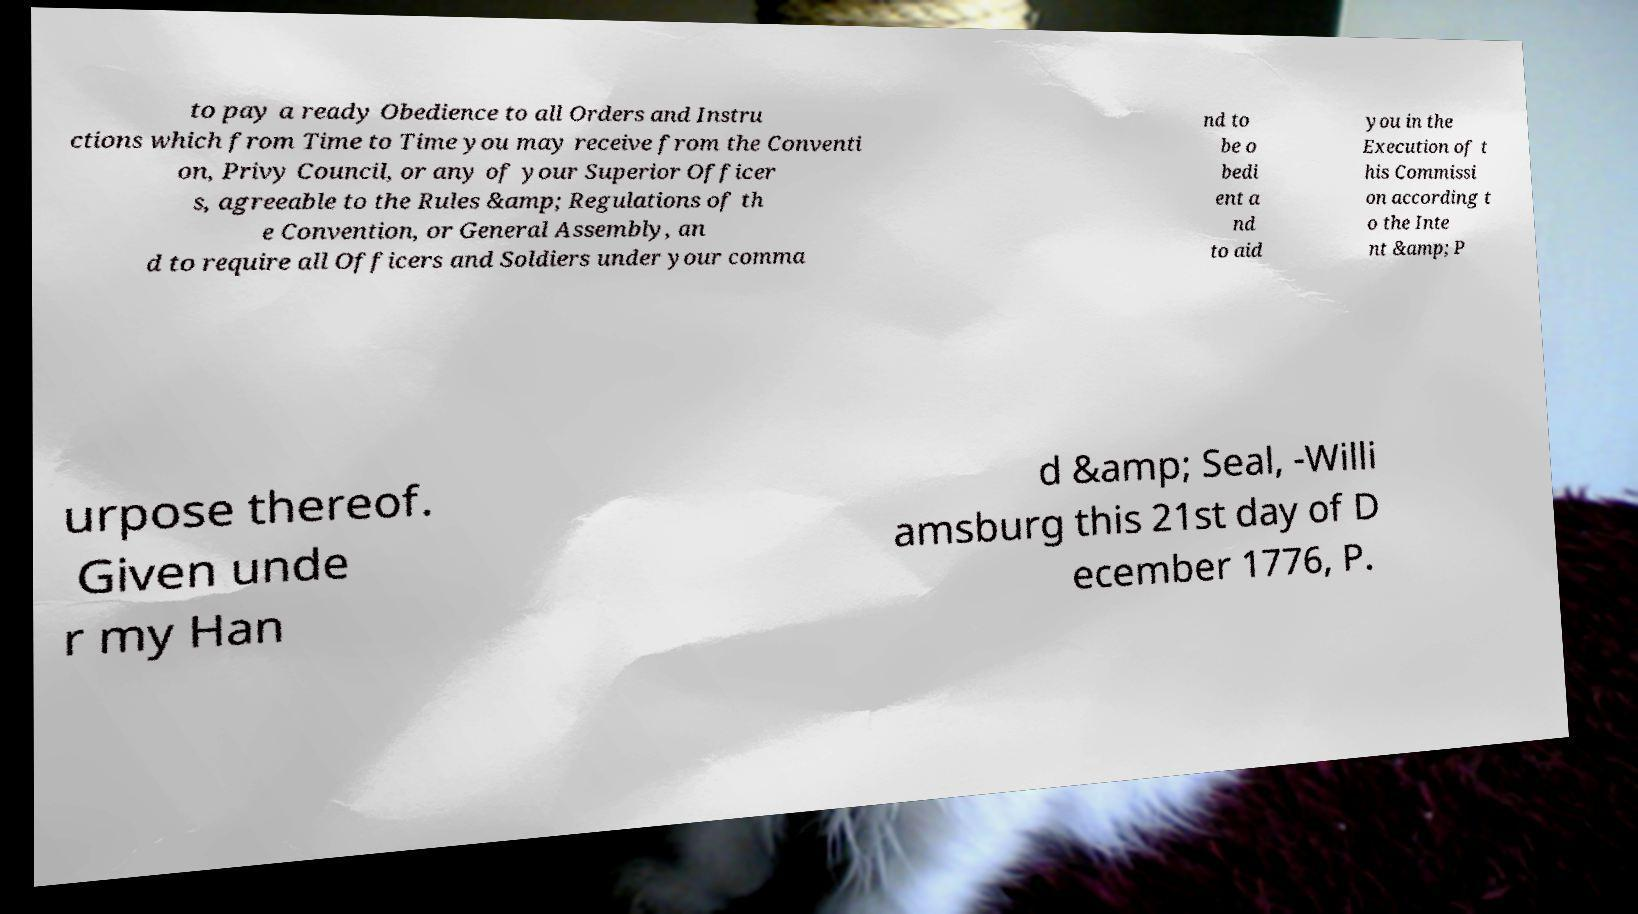I need the written content from this picture converted into text. Can you do that? to pay a ready Obedience to all Orders and Instru ctions which from Time to Time you may receive from the Conventi on, Privy Council, or any of your Superior Officer s, agreeable to the Rules &amp; Regulations of th e Convention, or General Assembly, an d to require all Officers and Soldiers under your comma nd to be o bedi ent a nd to aid you in the Execution of t his Commissi on according t o the Inte nt &amp; P urpose thereof. Given unde r my Han d &amp; Seal, -Willi amsburg this 21st day of D ecember 1776, P. 